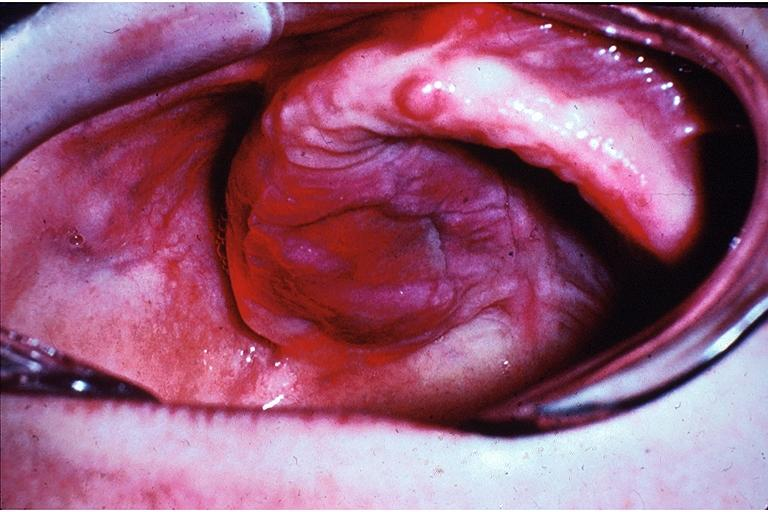s retroperitoneum present?
Answer the question using a single word or phrase. No 